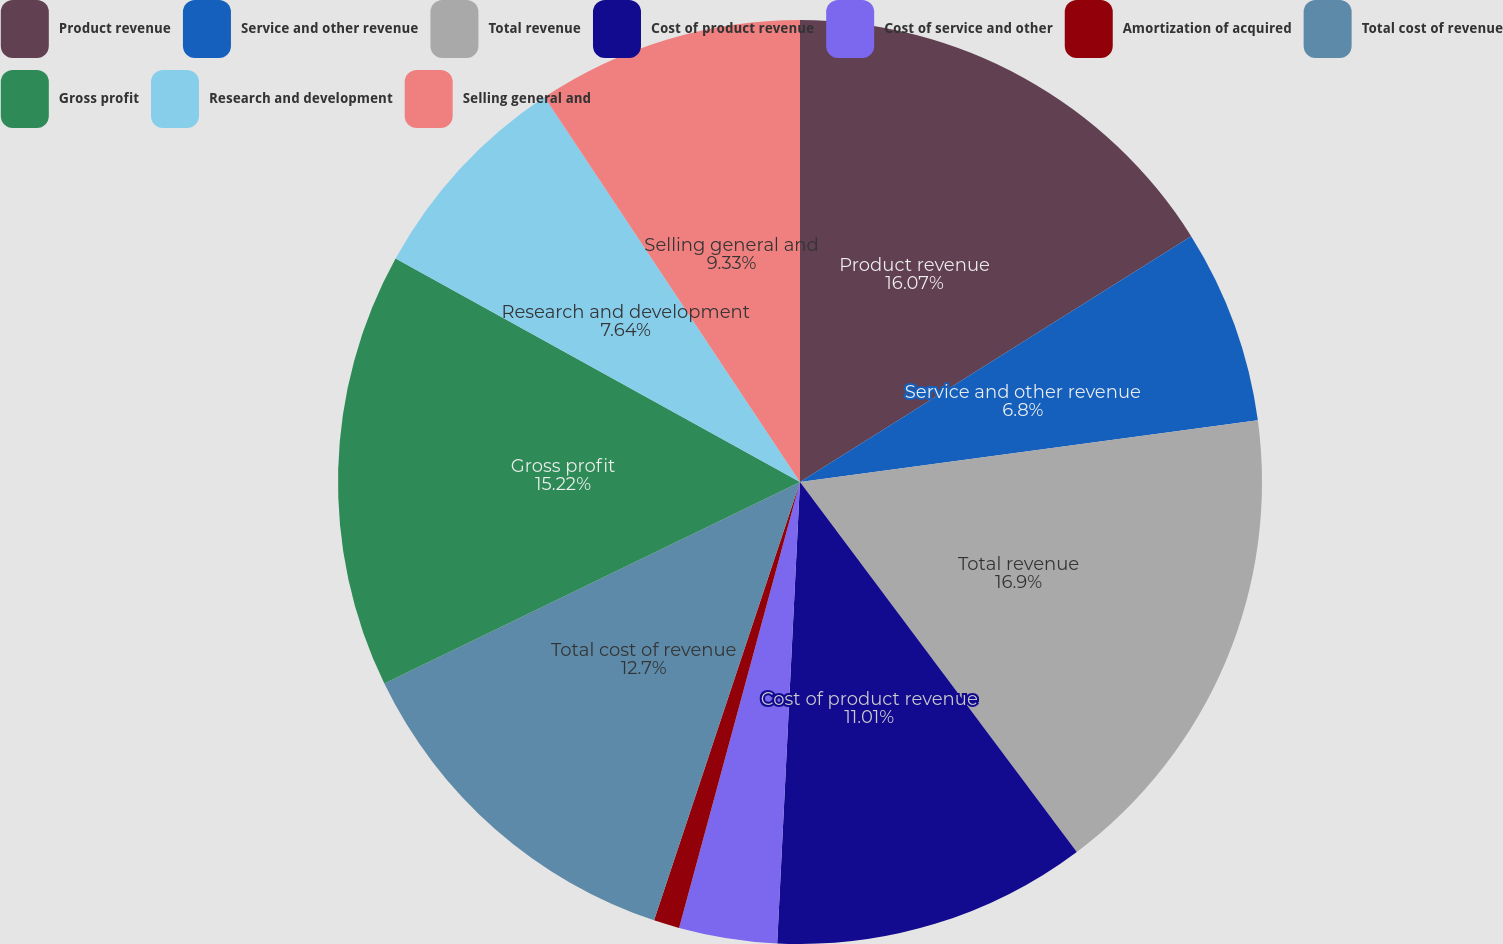<chart> <loc_0><loc_0><loc_500><loc_500><pie_chart><fcel>Product revenue<fcel>Service and other revenue<fcel>Total revenue<fcel>Cost of product revenue<fcel>Cost of service and other<fcel>Amortization of acquired<fcel>Total cost of revenue<fcel>Gross profit<fcel>Research and development<fcel>Selling general and<nl><fcel>16.07%<fcel>6.8%<fcel>16.91%<fcel>11.01%<fcel>3.43%<fcel>0.9%<fcel>12.7%<fcel>15.22%<fcel>7.64%<fcel>9.33%<nl></chart> 